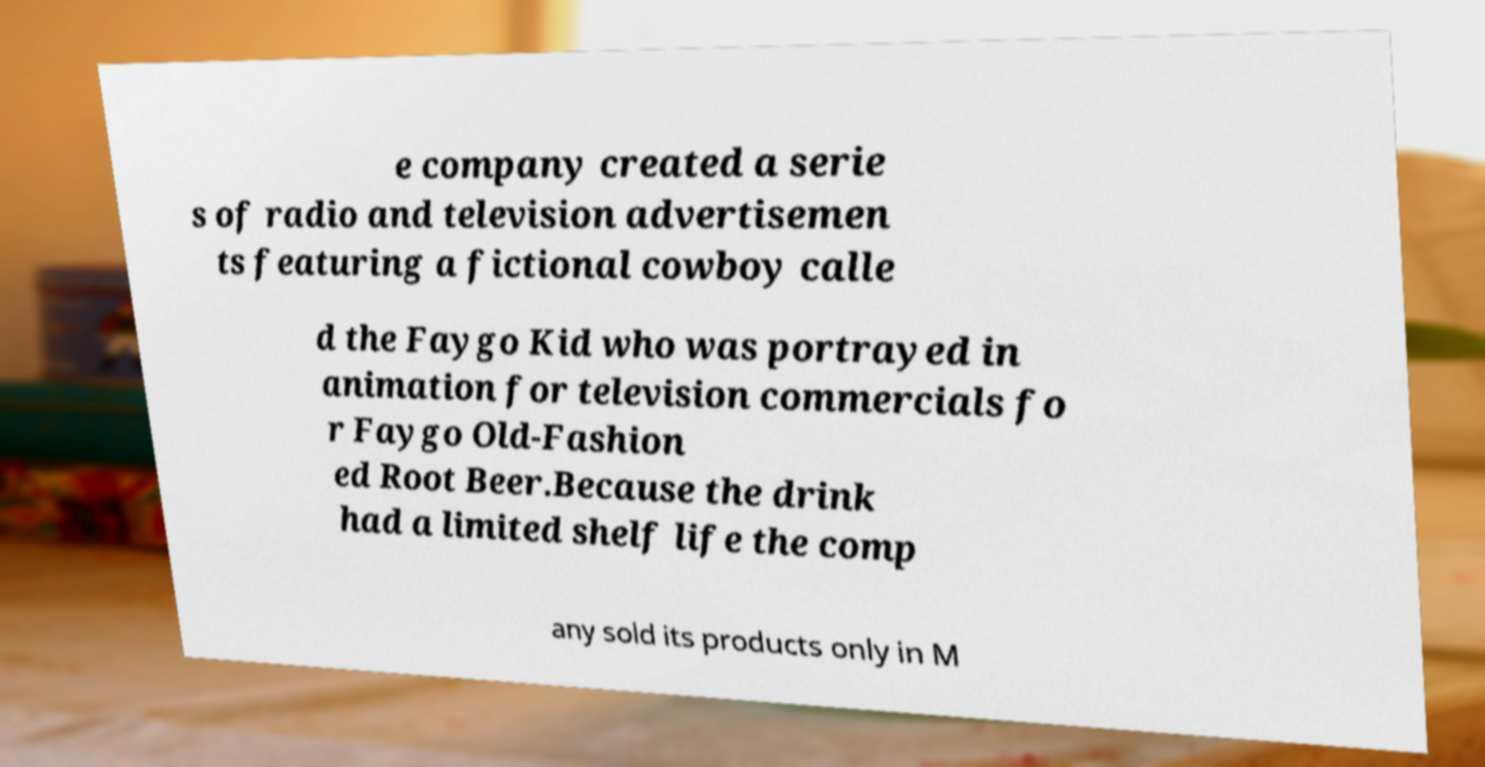I need the written content from this picture converted into text. Can you do that? e company created a serie s of radio and television advertisemen ts featuring a fictional cowboy calle d the Faygo Kid who was portrayed in animation for television commercials fo r Faygo Old-Fashion ed Root Beer.Because the drink had a limited shelf life the comp any sold its products only in M 